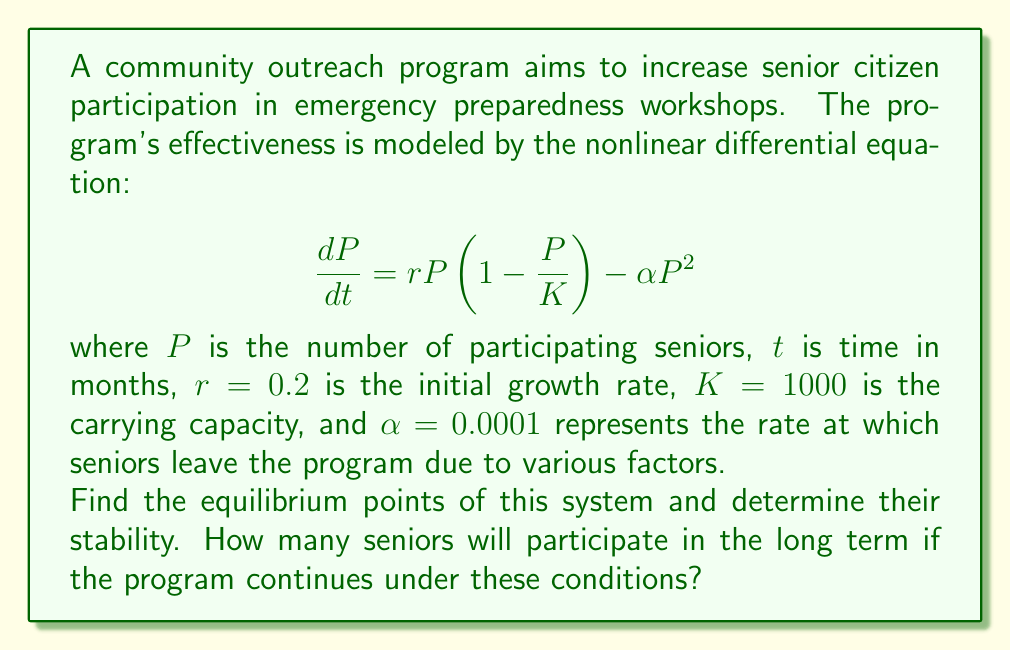Give your solution to this math problem. 1. To find the equilibrium points, we set $\frac{dP}{dt} = 0$:

   $$0 = rP(1-\frac{P}{K}) - \alpha P^2$$

2. Factor out $P$:

   $$0 = P(r(1-\frac{P}{K}) - \alpha P)$$

3. Solve for $P$:
   
   a) $P = 0$ is one equilibrium point.
   
   b) For the other point, solve:
      
      $$r(1-\frac{P}{K}) - \alpha P = 0$$
      
      $$r - \frac{rP}{K} - \alpha P = 0$$
      
      $$r = P(\frac{r}{K} + \alpha)$$
      
      $$P = \frac{r}{\frac{r}{K} + \alpha}$$

4. Substitute the given values:

   $$P = \frac{0.2}{\frac{0.2}{1000} + 0.0001} \approx 666.67$$

5. To determine stability, we evaluate the derivative of $\frac{dP}{dt}$ with respect to $P$ at each equilibrium point:

   $$\frac{d}{dP}(\frac{dP}{dt}) = r(1-\frac{2P}{K}) - 2\alpha P$$

   a) At $P = 0$: $\frac{d}{dP}(\frac{dP}{dt}) = r = 0.2 > 0$, so this is an unstable equilibrium.
   
   b) At $P \approx 666.67$: 
      
      $$\frac{d}{dP}(\frac{dP}{dt}) = 0.2(1-\frac{2(666.67)}{1000}) - 2(0.0001)(666.67) \approx -0.0667 < 0$$
      
      This is a stable equilibrium.

Therefore, in the long term, the number of participating seniors will approach the stable equilibrium point.
Answer: Approximately 667 seniors 